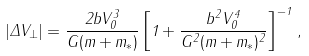Convert formula to latex. <formula><loc_0><loc_0><loc_500><loc_500>| \Delta { V } _ { \perp } | = \frac { 2 b V _ { 0 } ^ { 3 } } { G ( m + m _ { * } ) } \left [ 1 + \frac { b ^ { 2 } V _ { 0 } ^ { 4 } } { G ^ { 2 } ( m + m _ { * } ) ^ { 2 } } \right ] ^ { - 1 } \, ,</formula> 